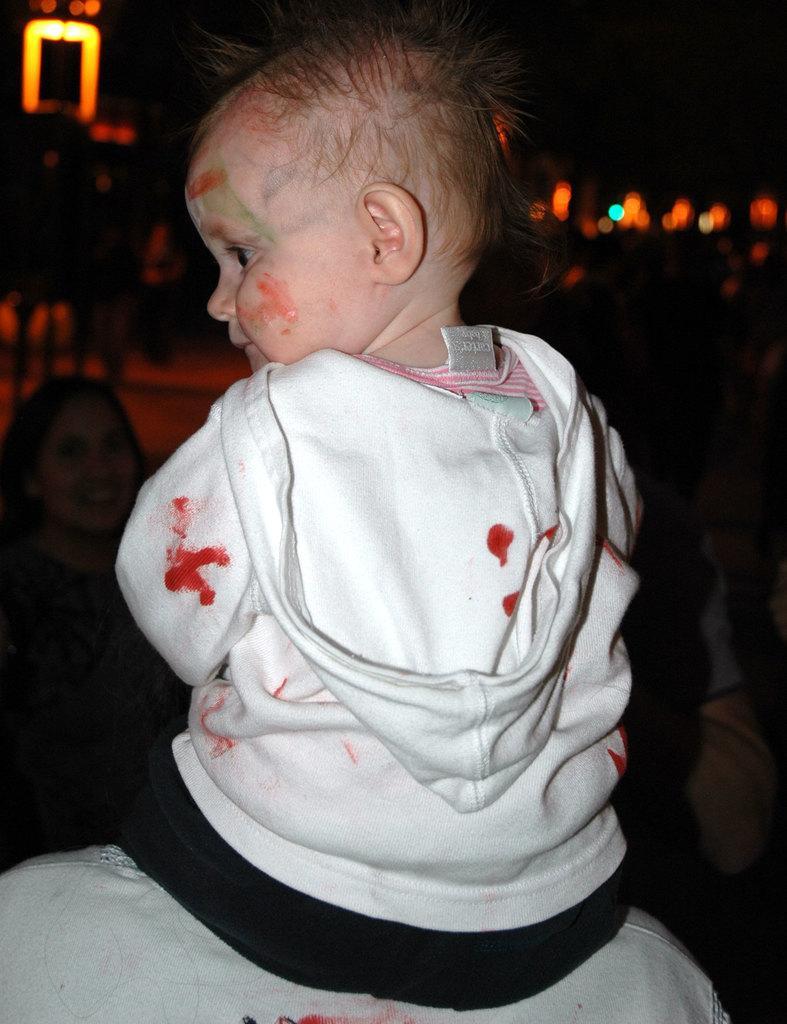Can you describe this image briefly? In this image there is a kid who is sitting on the shoulder of a person. In the background it is dark with some lights. On the left side there is a woman in front of the kid. On the right side there are few people standing in front of the kid. 